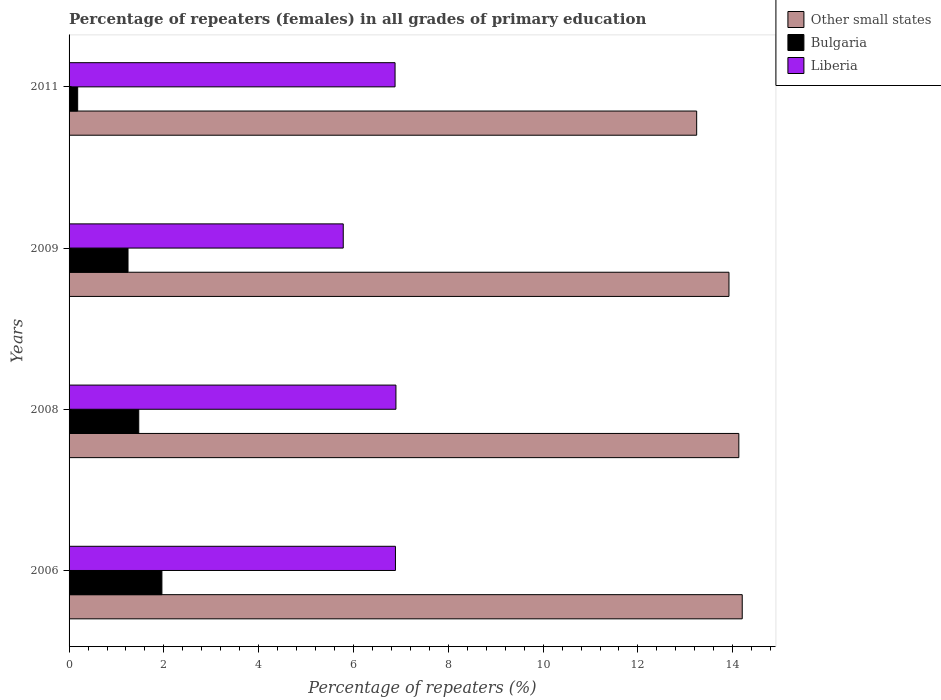How many different coloured bars are there?
Make the answer very short. 3. How many groups of bars are there?
Provide a short and direct response. 4. Are the number of bars per tick equal to the number of legend labels?
Provide a short and direct response. Yes. How many bars are there on the 2nd tick from the top?
Keep it short and to the point. 3. How many bars are there on the 1st tick from the bottom?
Offer a very short reply. 3. What is the label of the 1st group of bars from the top?
Your answer should be compact. 2011. What is the percentage of repeaters (females) in Other small states in 2009?
Your response must be concise. 13.92. Across all years, what is the maximum percentage of repeaters (females) in Bulgaria?
Offer a terse response. 1.96. Across all years, what is the minimum percentage of repeaters (females) in Liberia?
Ensure brevity in your answer.  5.78. In which year was the percentage of repeaters (females) in Bulgaria maximum?
Make the answer very short. 2006. In which year was the percentage of repeaters (females) in Liberia minimum?
Offer a terse response. 2009. What is the total percentage of repeaters (females) in Bulgaria in the graph?
Ensure brevity in your answer.  4.85. What is the difference between the percentage of repeaters (females) in Liberia in 2009 and that in 2011?
Your answer should be very brief. -1.09. What is the difference between the percentage of repeaters (females) in Other small states in 2006 and the percentage of repeaters (females) in Bulgaria in 2008?
Provide a succinct answer. 12.73. What is the average percentage of repeaters (females) in Bulgaria per year?
Your answer should be very brief. 1.21. In the year 2009, what is the difference between the percentage of repeaters (females) in Bulgaria and percentage of repeaters (females) in Liberia?
Keep it short and to the point. -4.54. What is the ratio of the percentage of repeaters (females) in Other small states in 2006 to that in 2009?
Offer a very short reply. 1.02. Is the percentage of repeaters (females) in Bulgaria in 2009 less than that in 2011?
Provide a short and direct response. No. What is the difference between the highest and the second highest percentage of repeaters (females) in Liberia?
Your answer should be compact. 0.01. What is the difference between the highest and the lowest percentage of repeaters (females) in Bulgaria?
Provide a succinct answer. 1.78. In how many years, is the percentage of repeaters (females) in Liberia greater than the average percentage of repeaters (females) in Liberia taken over all years?
Offer a very short reply. 3. What does the 2nd bar from the top in 2008 represents?
Give a very brief answer. Bulgaria. What does the 3rd bar from the bottom in 2009 represents?
Your answer should be compact. Liberia. Are all the bars in the graph horizontal?
Your answer should be compact. Yes. Does the graph contain any zero values?
Provide a short and direct response. No. Where does the legend appear in the graph?
Keep it short and to the point. Top right. How are the legend labels stacked?
Your answer should be compact. Vertical. What is the title of the graph?
Offer a terse response. Percentage of repeaters (females) in all grades of primary education. Does "Suriname" appear as one of the legend labels in the graph?
Your response must be concise. No. What is the label or title of the X-axis?
Provide a succinct answer. Percentage of repeaters (%). What is the label or title of the Y-axis?
Ensure brevity in your answer.  Years. What is the Percentage of repeaters (%) in Other small states in 2006?
Offer a terse response. 14.2. What is the Percentage of repeaters (%) of Bulgaria in 2006?
Offer a very short reply. 1.96. What is the Percentage of repeaters (%) in Liberia in 2006?
Offer a terse response. 6.88. What is the Percentage of repeaters (%) of Other small states in 2008?
Keep it short and to the point. 14.13. What is the Percentage of repeaters (%) in Bulgaria in 2008?
Give a very brief answer. 1.47. What is the Percentage of repeaters (%) of Liberia in 2008?
Make the answer very short. 6.9. What is the Percentage of repeaters (%) of Other small states in 2009?
Keep it short and to the point. 13.92. What is the Percentage of repeaters (%) of Bulgaria in 2009?
Offer a terse response. 1.24. What is the Percentage of repeaters (%) in Liberia in 2009?
Your response must be concise. 5.78. What is the Percentage of repeaters (%) of Other small states in 2011?
Provide a succinct answer. 13.24. What is the Percentage of repeaters (%) of Bulgaria in 2011?
Give a very brief answer. 0.18. What is the Percentage of repeaters (%) in Liberia in 2011?
Give a very brief answer. 6.88. Across all years, what is the maximum Percentage of repeaters (%) of Other small states?
Give a very brief answer. 14.2. Across all years, what is the maximum Percentage of repeaters (%) in Bulgaria?
Your answer should be very brief. 1.96. Across all years, what is the maximum Percentage of repeaters (%) of Liberia?
Your answer should be very brief. 6.9. Across all years, what is the minimum Percentage of repeaters (%) in Other small states?
Your response must be concise. 13.24. Across all years, what is the minimum Percentage of repeaters (%) in Bulgaria?
Make the answer very short. 0.18. Across all years, what is the minimum Percentage of repeaters (%) of Liberia?
Keep it short and to the point. 5.78. What is the total Percentage of repeaters (%) of Other small states in the graph?
Your response must be concise. 55.49. What is the total Percentage of repeaters (%) in Bulgaria in the graph?
Make the answer very short. 4.85. What is the total Percentage of repeaters (%) of Liberia in the graph?
Give a very brief answer. 26.44. What is the difference between the Percentage of repeaters (%) in Other small states in 2006 and that in 2008?
Keep it short and to the point. 0.07. What is the difference between the Percentage of repeaters (%) of Bulgaria in 2006 and that in 2008?
Your response must be concise. 0.49. What is the difference between the Percentage of repeaters (%) in Liberia in 2006 and that in 2008?
Your response must be concise. -0.01. What is the difference between the Percentage of repeaters (%) in Other small states in 2006 and that in 2009?
Your answer should be compact. 0.28. What is the difference between the Percentage of repeaters (%) in Bulgaria in 2006 and that in 2009?
Provide a short and direct response. 0.71. What is the difference between the Percentage of repeaters (%) in Liberia in 2006 and that in 2009?
Offer a very short reply. 1.1. What is the difference between the Percentage of repeaters (%) in Other small states in 2006 and that in 2011?
Provide a succinct answer. 0.96. What is the difference between the Percentage of repeaters (%) in Bulgaria in 2006 and that in 2011?
Ensure brevity in your answer.  1.78. What is the difference between the Percentage of repeaters (%) in Liberia in 2006 and that in 2011?
Your response must be concise. 0.01. What is the difference between the Percentage of repeaters (%) in Other small states in 2008 and that in 2009?
Offer a terse response. 0.21. What is the difference between the Percentage of repeaters (%) in Bulgaria in 2008 and that in 2009?
Provide a short and direct response. 0.23. What is the difference between the Percentage of repeaters (%) in Liberia in 2008 and that in 2009?
Make the answer very short. 1.11. What is the difference between the Percentage of repeaters (%) in Other small states in 2008 and that in 2011?
Your answer should be very brief. 0.89. What is the difference between the Percentage of repeaters (%) of Bulgaria in 2008 and that in 2011?
Provide a succinct answer. 1.29. What is the difference between the Percentage of repeaters (%) of Liberia in 2008 and that in 2011?
Offer a terse response. 0.02. What is the difference between the Percentage of repeaters (%) in Other small states in 2009 and that in 2011?
Offer a terse response. 0.68. What is the difference between the Percentage of repeaters (%) of Bulgaria in 2009 and that in 2011?
Keep it short and to the point. 1.06. What is the difference between the Percentage of repeaters (%) of Liberia in 2009 and that in 2011?
Offer a terse response. -1.09. What is the difference between the Percentage of repeaters (%) of Other small states in 2006 and the Percentage of repeaters (%) of Bulgaria in 2008?
Provide a short and direct response. 12.73. What is the difference between the Percentage of repeaters (%) of Other small states in 2006 and the Percentage of repeaters (%) of Liberia in 2008?
Provide a succinct answer. 7.31. What is the difference between the Percentage of repeaters (%) of Bulgaria in 2006 and the Percentage of repeaters (%) of Liberia in 2008?
Provide a succinct answer. -4.94. What is the difference between the Percentage of repeaters (%) of Other small states in 2006 and the Percentage of repeaters (%) of Bulgaria in 2009?
Your answer should be compact. 12.96. What is the difference between the Percentage of repeaters (%) in Other small states in 2006 and the Percentage of repeaters (%) in Liberia in 2009?
Your response must be concise. 8.42. What is the difference between the Percentage of repeaters (%) in Bulgaria in 2006 and the Percentage of repeaters (%) in Liberia in 2009?
Provide a succinct answer. -3.83. What is the difference between the Percentage of repeaters (%) in Other small states in 2006 and the Percentage of repeaters (%) in Bulgaria in 2011?
Keep it short and to the point. 14.02. What is the difference between the Percentage of repeaters (%) of Other small states in 2006 and the Percentage of repeaters (%) of Liberia in 2011?
Provide a short and direct response. 7.32. What is the difference between the Percentage of repeaters (%) in Bulgaria in 2006 and the Percentage of repeaters (%) in Liberia in 2011?
Ensure brevity in your answer.  -4.92. What is the difference between the Percentage of repeaters (%) of Other small states in 2008 and the Percentage of repeaters (%) of Bulgaria in 2009?
Provide a succinct answer. 12.89. What is the difference between the Percentage of repeaters (%) of Other small states in 2008 and the Percentage of repeaters (%) of Liberia in 2009?
Your answer should be very brief. 8.34. What is the difference between the Percentage of repeaters (%) of Bulgaria in 2008 and the Percentage of repeaters (%) of Liberia in 2009?
Offer a terse response. -4.31. What is the difference between the Percentage of repeaters (%) of Other small states in 2008 and the Percentage of repeaters (%) of Bulgaria in 2011?
Offer a terse response. 13.95. What is the difference between the Percentage of repeaters (%) in Other small states in 2008 and the Percentage of repeaters (%) in Liberia in 2011?
Offer a very short reply. 7.25. What is the difference between the Percentage of repeaters (%) of Bulgaria in 2008 and the Percentage of repeaters (%) of Liberia in 2011?
Ensure brevity in your answer.  -5.41. What is the difference between the Percentage of repeaters (%) of Other small states in 2009 and the Percentage of repeaters (%) of Bulgaria in 2011?
Your answer should be very brief. 13.74. What is the difference between the Percentage of repeaters (%) in Other small states in 2009 and the Percentage of repeaters (%) in Liberia in 2011?
Ensure brevity in your answer.  7.04. What is the difference between the Percentage of repeaters (%) in Bulgaria in 2009 and the Percentage of repeaters (%) in Liberia in 2011?
Give a very brief answer. -5.63. What is the average Percentage of repeaters (%) in Other small states per year?
Ensure brevity in your answer.  13.87. What is the average Percentage of repeaters (%) in Bulgaria per year?
Ensure brevity in your answer.  1.21. What is the average Percentage of repeaters (%) of Liberia per year?
Offer a very short reply. 6.61. In the year 2006, what is the difference between the Percentage of repeaters (%) in Other small states and Percentage of repeaters (%) in Bulgaria?
Give a very brief answer. 12.24. In the year 2006, what is the difference between the Percentage of repeaters (%) of Other small states and Percentage of repeaters (%) of Liberia?
Your answer should be very brief. 7.32. In the year 2006, what is the difference between the Percentage of repeaters (%) of Bulgaria and Percentage of repeaters (%) of Liberia?
Keep it short and to the point. -4.93. In the year 2008, what is the difference between the Percentage of repeaters (%) of Other small states and Percentage of repeaters (%) of Bulgaria?
Give a very brief answer. 12.66. In the year 2008, what is the difference between the Percentage of repeaters (%) in Other small states and Percentage of repeaters (%) in Liberia?
Give a very brief answer. 7.23. In the year 2008, what is the difference between the Percentage of repeaters (%) in Bulgaria and Percentage of repeaters (%) in Liberia?
Provide a succinct answer. -5.43. In the year 2009, what is the difference between the Percentage of repeaters (%) of Other small states and Percentage of repeaters (%) of Bulgaria?
Give a very brief answer. 12.68. In the year 2009, what is the difference between the Percentage of repeaters (%) in Other small states and Percentage of repeaters (%) in Liberia?
Your answer should be compact. 8.14. In the year 2009, what is the difference between the Percentage of repeaters (%) in Bulgaria and Percentage of repeaters (%) in Liberia?
Offer a very short reply. -4.54. In the year 2011, what is the difference between the Percentage of repeaters (%) in Other small states and Percentage of repeaters (%) in Bulgaria?
Give a very brief answer. 13.06. In the year 2011, what is the difference between the Percentage of repeaters (%) in Other small states and Percentage of repeaters (%) in Liberia?
Your answer should be compact. 6.36. In the year 2011, what is the difference between the Percentage of repeaters (%) in Bulgaria and Percentage of repeaters (%) in Liberia?
Provide a short and direct response. -6.7. What is the ratio of the Percentage of repeaters (%) in Bulgaria in 2006 to that in 2008?
Make the answer very short. 1.33. What is the ratio of the Percentage of repeaters (%) in Other small states in 2006 to that in 2009?
Make the answer very short. 1.02. What is the ratio of the Percentage of repeaters (%) in Bulgaria in 2006 to that in 2009?
Provide a succinct answer. 1.57. What is the ratio of the Percentage of repeaters (%) of Liberia in 2006 to that in 2009?
Make the answer very short. 1.19. What is the ratio of the Percentage of repeaters (%) in Other small states in 2006 to that in 2011?
Your response must be concise. 1.07. What is the ratio of the Percentage of repeaters (%) in Bulgaria in 2006 to that in 2011?
Provide a succinct answer. 10.79. What is the ratio of the Percentage of repeaters (%) of Liberia in 2006 to that in 2011?
Offer a very short reply. 1. What is the ratio of the Percentage of repeaters (%) of Other small states in 2008 to that in 2009?
Offer a terse response. 1.01. What is the ratio of the Percentage of repeaters (%) in Bulgaria in 2008 to that in 2009?
Provide a succinct answer. 1.18. What is the ratio of the Percentage of repeaters (%) of Liberia in 2008 to that in 2009?
Provide a short and direct response. 1.19. What is the ratio of the Percentage of repeaters (%) of Other small states in 2008 to that in 2011?
Provide a short and direct response. 1.07. What is the ratio of the Percentage of repeaters (%) in Bulgaria in 2008 to that in 2011?
Keep it short and to the point. 8.1. What is the ratio of the Percentage of repeaters (%) of Other small states in 2009 to that in 2011?
Offer a very short reply. 1.05. What is the ratio of the Percentage of repeaters (%) in Bulgaria in 2009 to that in 2011?
Keep it short and to the point. 6.85. What is the ratio of the Percentage of repeaters (%) of Liberia in 2009 to that in 2011?
Ensure brevity in your answer.  0.84. What is the difference between the highest and the second highest Percentage of repeaters (%) in Other small states?
Make the answer very short. 0.07. What is the difference between the highest and the second highest Percentage of repeaters (%) of Bulgaria?
Make the answer very short. 0.49. What is the difference between the highest and the second highest Percentage of repeaters (%) of Liberia?
Your response must be concise. 0.01. What is the difference between the highest and the lowest Percentage of repeaters (%) in Other small states?
Your response must be concise. 0.96. What is the difference between the highest and the lowest Percentage of repeaters (%) in Bulgaria?
Offer a very short reply. 1.78. What is the difference between the highest and the lowest Percentage of repeaters (%) in Liberia?
Your response must be concise. 1.11. 